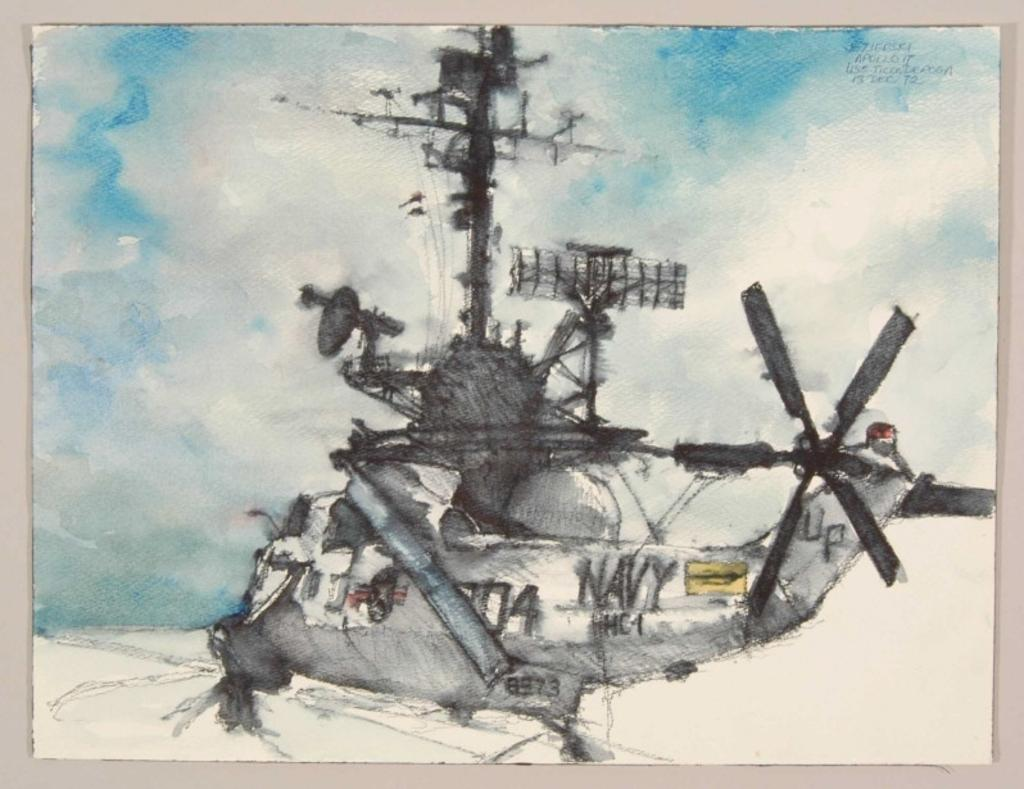Provide a one-sentence caption for the provided image. A grey Navy helicopter with UP on the tail. 